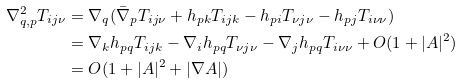<formula> <loc_0><loc_0><loc_500><loc_500>\nabla ^ { 2 } _ { q , p } T _ { i j \nu } & = \nabla _ { q } ( \bar { \nabla } _ { p } T _ { i j \nu } + h _ { p k } T _ { i j k } - h _ { p i } T _ { \nu j \nu } - h _ { p j } T _ { i \nu \nu } ) \\ & = \nabla _ { k } h _ { p q } T _ { i j k } - \nabla _ { i } h _ { p q } T _ { \nu j \nu } - \nabla _ { j } h _ { p q } T _ { i \nu \nu } + O ( 1 + | A | ^ { 2 } ) \\ & = O ( 1 + | A | ^ { 2 } + | \nabla A | )</formula> 